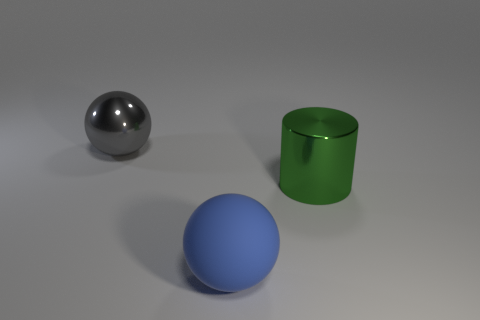What material do the objects in the image most likely resemble? The blue sphere resembles a matte plastic, the silver sphere looks like polished metal, and the green cylinder reminds me of colored glass with a satin finish. 